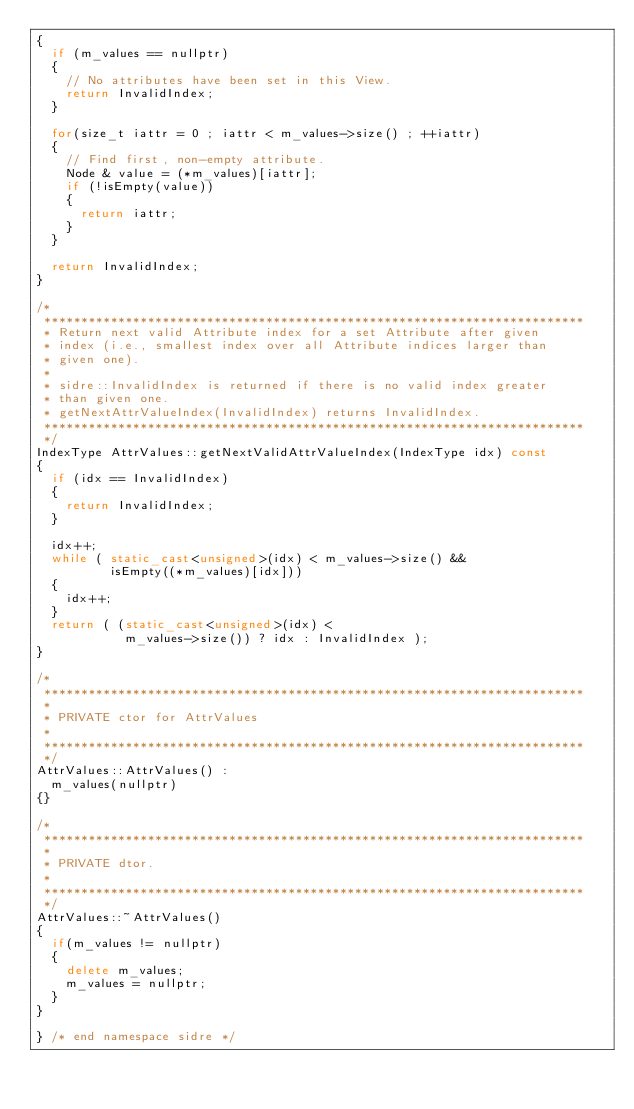<code> <loc_0><loc_0><loc_500><loc_500><_C++_>{
  if (m_values == nullptr)
  {
    // No attributes have been set in this View.
    return InvalidIndex;
  }

  for(size_t iattr = 0 ; iattr < m_values->size() ; ++iattr)
  {
    // Find first, non-empty attribute.
    Node & value = (*m_values)[iattr];
    if (!isEmpty(value))
    {
      return iattr;
    }
  }

  return InvalidIndex;
}

/*
 *************************************************************************
 * Return next valid Attribute index for a set Attribute after given
 * index (i.e., smallest index over all Attribute indices larger than
 * given one).
 *
 * sidre::InvalidIndex is returned if there is no valid index greater
 * than given one.
 * getNextAttrValueIndex(InvalidIndex) returns InvalidIndex.
 *************************************************************************
 */
IndexType AttrValues::getNextValidAttrValueIndex(IndexType idx) const
{
  if (idx == InvalidIndex)
  {
    return InvalidIndex;
  }

  idx++;
  while ( static_cast<unsigned>(idx) < m_values->size() &&
          isEmpty((*m_values)[idx]))
  {
    idx++;
  }
  return ( (static_cast<unsigned>(idx) <
            m_values->size()) ? idx : InvalidIndex );
}

/*
 *************************************************************************
 *
 * PRIVATE ctor for AttrValues
 *
 *************************************************************************
 */
AttrValues::AttrValues() :
  m_values(nullptr)
{}

/*
 *************************************************************************
 *
 * PRIVATE dtor.
 *
 *************************************************************************
 */
AttrValues::~AttrValues()
{
  if(m_values != nullptr)
  {
    delete m_values;
    m_values = nullptr;
  }
}

} /* end namespace sidre */</code> 